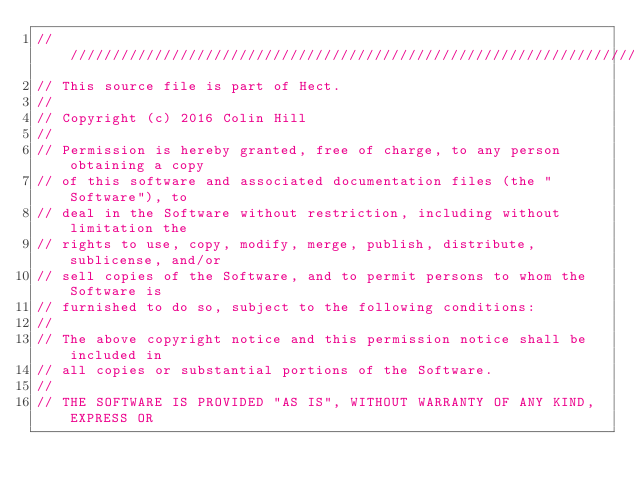Convert code to text. <code><loc_0><loc_0><loc_500><loc_500><_C_>///////////////////////////////////////////////////////////////////////////////
// This source file is part of Hect.
//
// Copyright (c) 2016 Colin Hill
//
// Permission is hereby granted, free of charge, to any person obtaining a copy
// of this software and associated documentation files (the "Software"), to
// deal in the Software without restriction, including without limitation the
// rights to use, copy, modify, merge, publish, distribute, sublicense, and/or
// sell copies of the Software, and to permit persons to whom the Software is
// furnished to do so, subject to the following conditions:
//
// The above copyright notice and this permission notice shall be included in
// all copies or substantial portions of the Software.
//
// THE SOFTWARE IS PROVIDED "AS IS", WITHOUT WARRANTY OF ANY KIND, EXPRESS OR</code> 